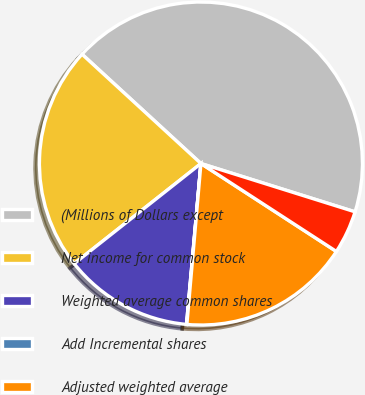Convert chart. <chart><loc_0><loc_0><loc_500><loc_500><pie_chart><fcel>(Millions of Dollars except<fcel>Net income for common stock<fcel>Weighted average common shares<fcel>Add Incremental shares<fcel>Adjusted weighted average<fcel>Net Income for common stock<nl><fcel>43.0%<fcel>22.47%<fcel>12.93%<fcel>0.04%<fcel>17.22%<fcel>4.33%<nl></chart> 